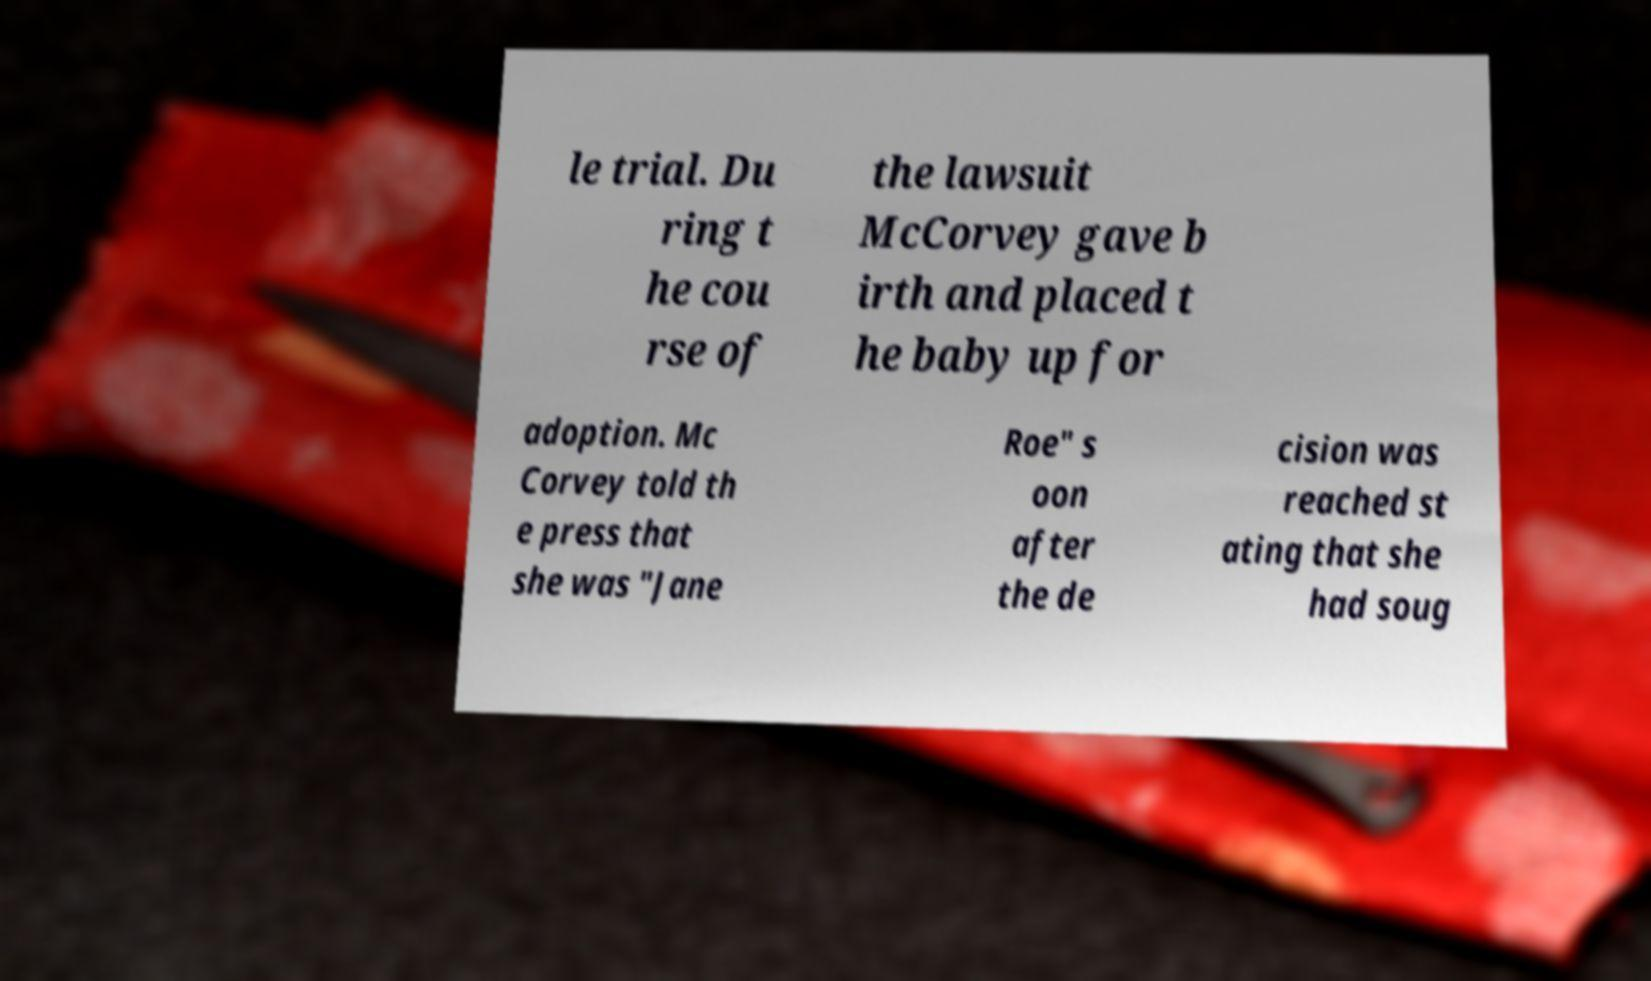I need the written content from this picture converted into text. Can you do that? le trial. Du ring t he cou rse of the lawsuit McCorvey gave b irth and placed t he baby up for adoption. Mc Corvey told th e press that she was "Jane Roe" s oon after the de cision was reached st ating that she had soug 